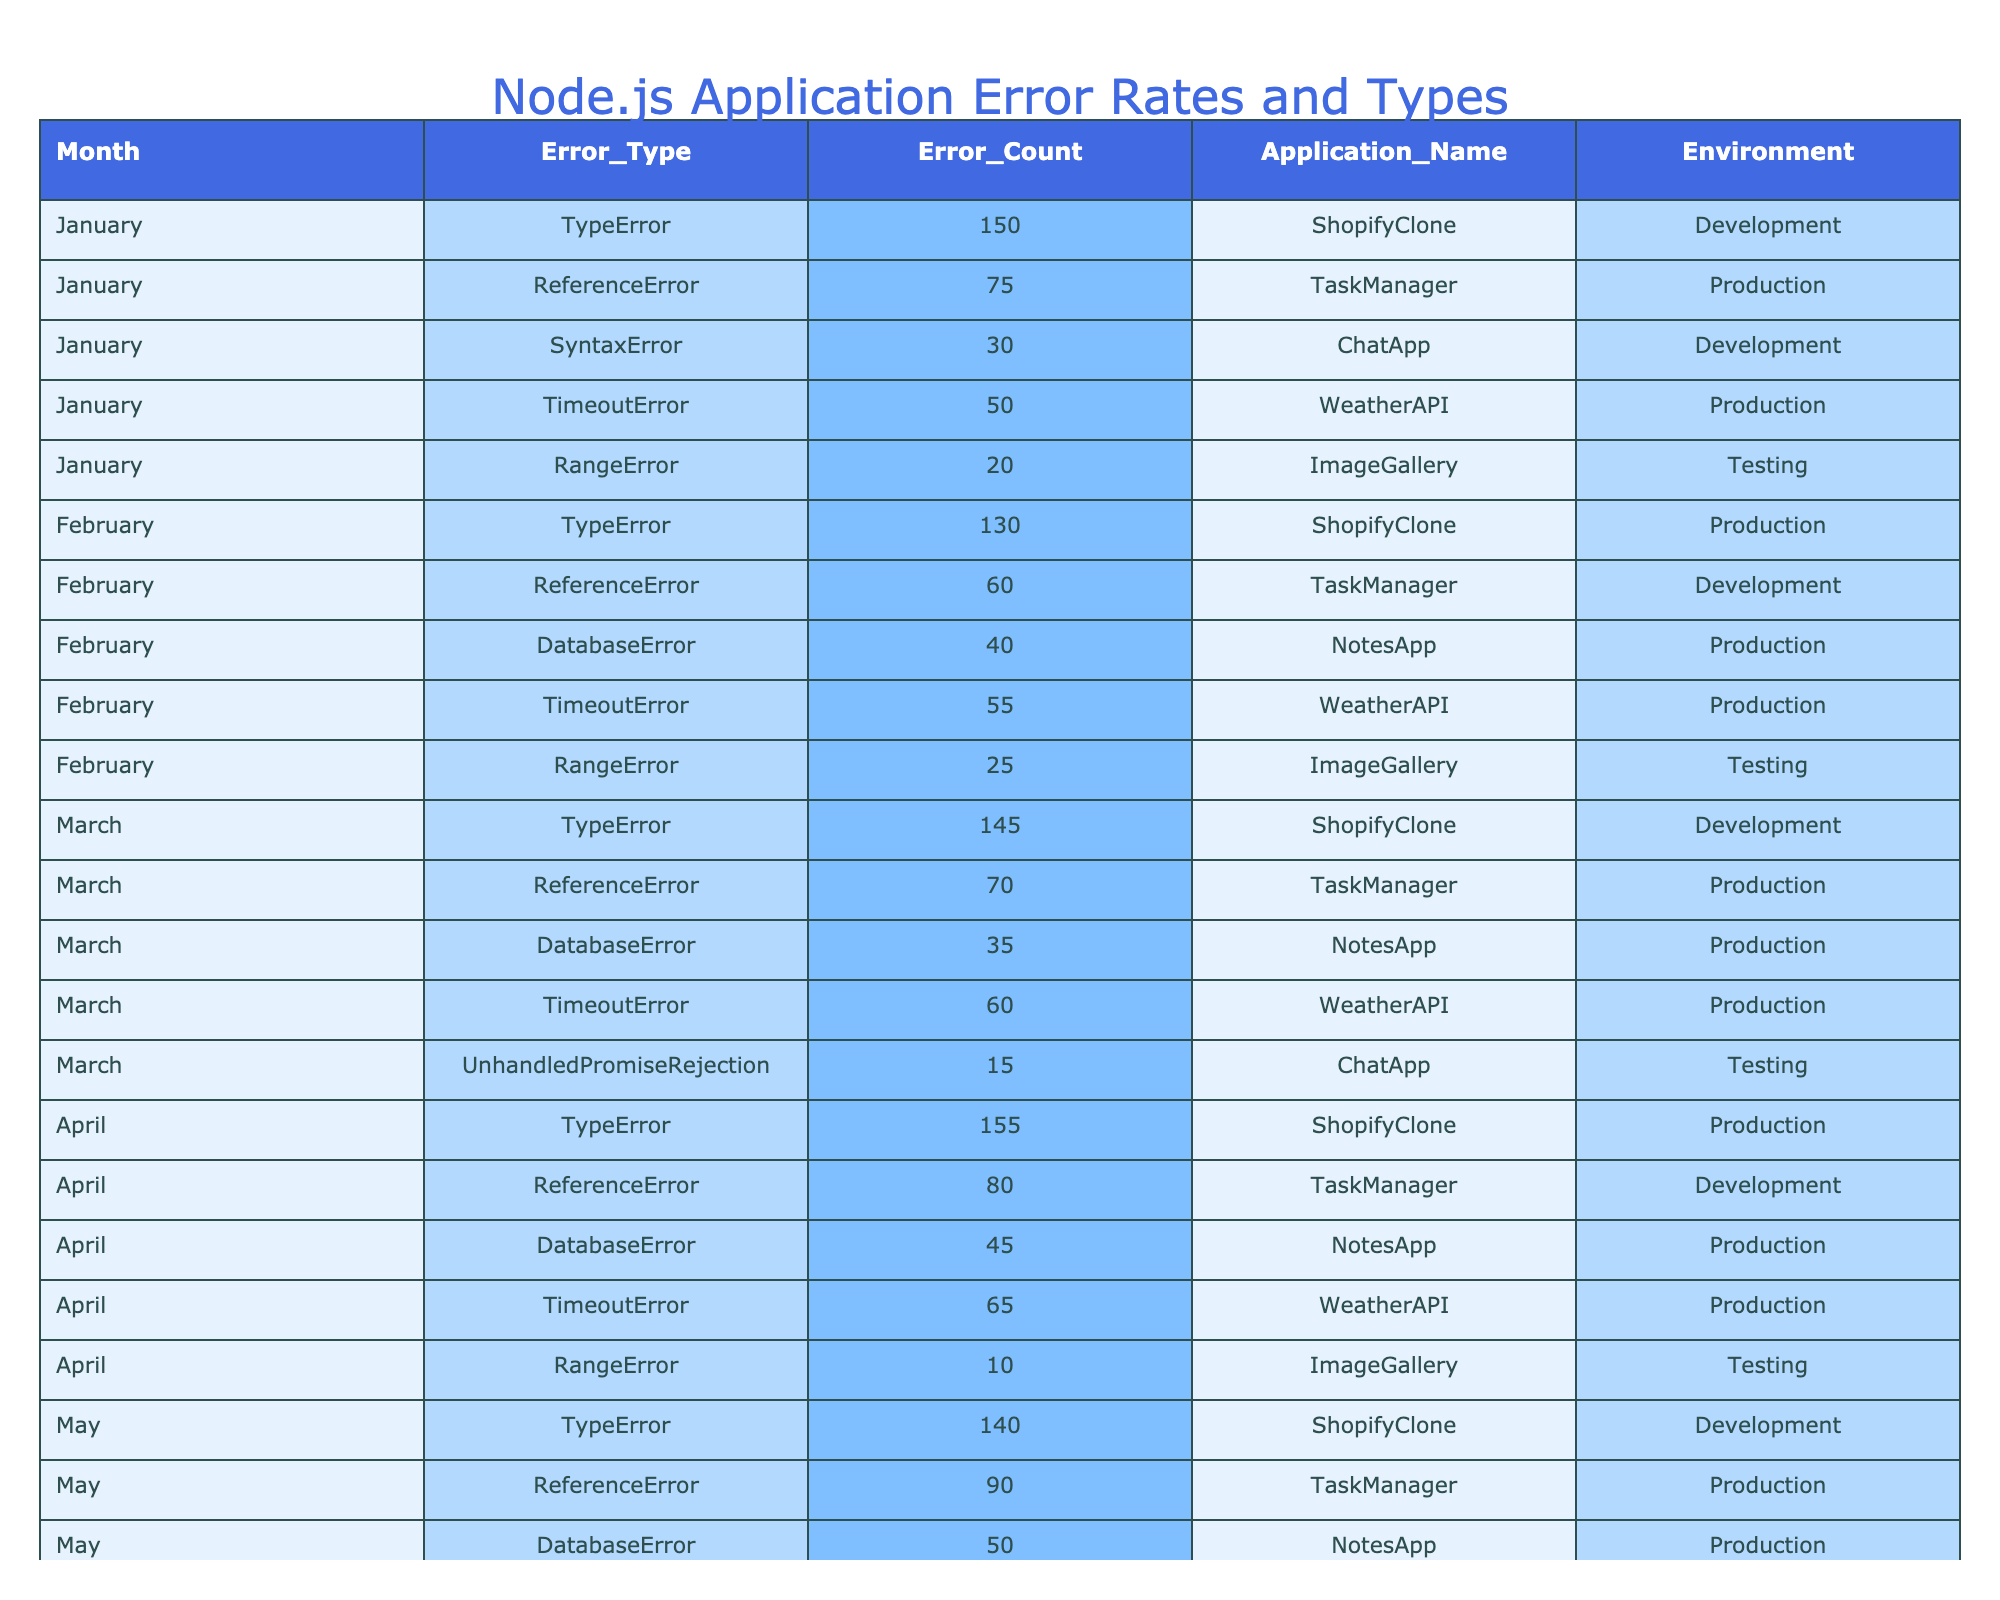What is the total number of TypeErrors in November? Looking at the table, the TypeErrors for November is listed as 175. Therefore, the total number of TypeErrors in November is 175.
Answer: 175 What is the error type with the highest count in December? The December data shows TypeError with a count of 190, which is higher than all other error types in that month. Therefore, the error type with the highest count in December is TypeError.
Answer: TypeError In which month did DatabaseError reach its maximum value? Checking the DatabaseError counts across the months, the highest count is 80 in November. Therefore, November is the month when DatabaseError reached its maximum value.
Answer: November What is the average TimeoutError count across the entire year? The TimeoutError counts by month are: 50, 55, 60, 65, 70, 72, 80, 78, 75, 77, 79, and 85. Adding these values gives a total of 908. There are 12 months, so the average is 908 divided by 12, which equals approximately 75.67.
Answer: 75.67 Did the ReferenceError counts ever exceed 100 in any month? ReferenceError counts are as follows: 75, 60, 70, 80, 90, 85, 100, 95, 110, 120, 115, and 125. Notably, the counts exceeded 100 in the last three months of the year: September (110), October (120), and November (115), confirming that yes, it did exceed 100.
Answer: Yes Which application had the least number of RangeErrors in April? The table indicates that ImageGallery had only 10 RangeErrors in April, which is fewer than the count in any other month. Therefore, ImageGallery had the least number of RangeErrors in April.
Answer: ImageGallery What is the total count of UnhandledPromiseRejection errors across the year? UnhandledPromiseRejection counts are: 0 (not listed) for January, 0 for February, 15 for March, 25 for May, 30 for July, 35 for September, 0 for October, and 40 for November. Adding these counts gives a total of 145.
Answer: 145 Which month had the highest combined errors (total of all error types) for the ShopifyClone application? Calculating the total error counts for ShopifyClone: January (150), February (130), March (145), April (155), May (140), June (135), July (160), August (170), September (165), October (180), and November (175). The highest total of 190 is in December.
Answer: December How many errors were reported in the Testing environment across the year? The counts in the Testing environment by month are: 20 (April), 18 (June), 20 (August), 15 (October), and 22 (December). Summing these yields 95 errors across the year.
Answer: 95 